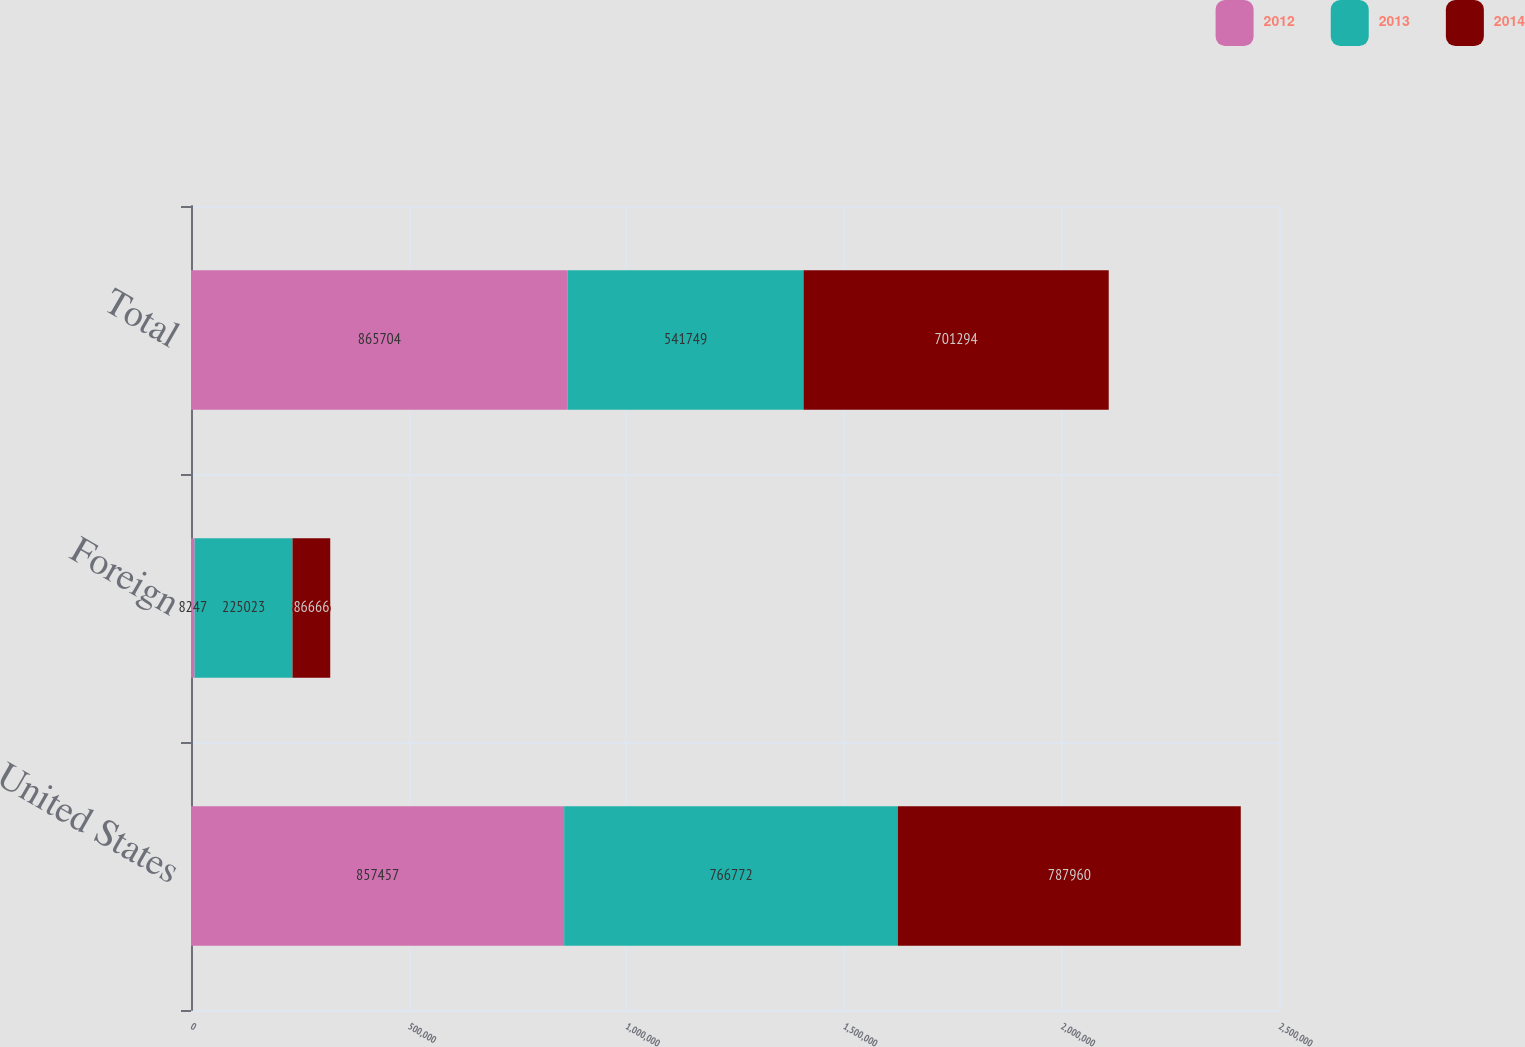Convert chart to OTSL. <chart><loc_0><loc_0><loc_500><loc_500><stacked_bar_chart><ecel><fcel>United States<fcel>Foreign<fcel>Total<nl><fcel>2012<fcel>857457<fcel>8247<fcel>865704<nl><fcel>2013<fcel>766772<fcel>225023<fcel>541749<nl><fcel>2014<fcel>787960<fcel>86666<fcel>701294<nl></chart> 